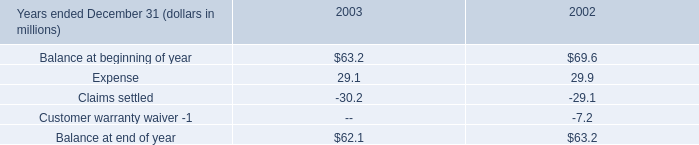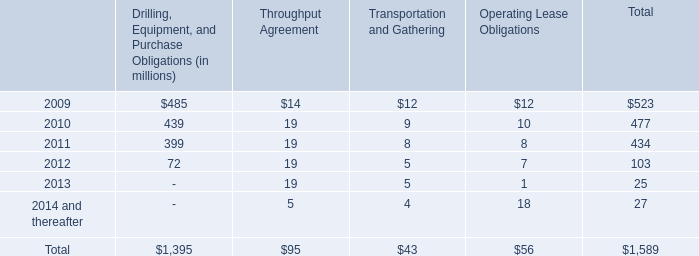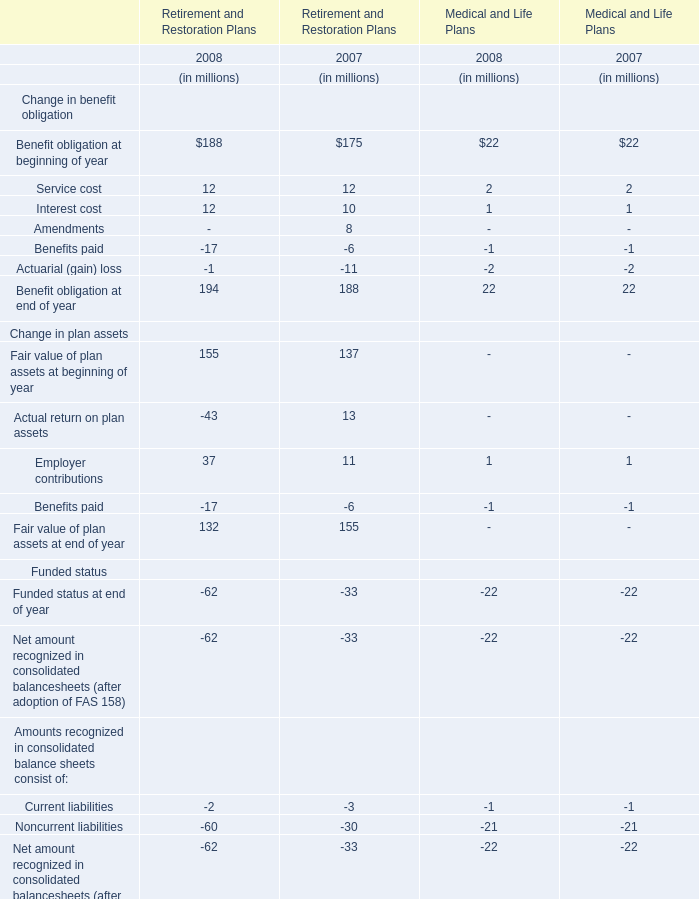In which year is Employer contributions for Retirement and Restoration Plans greater than 30? 
Answer: 2008. 